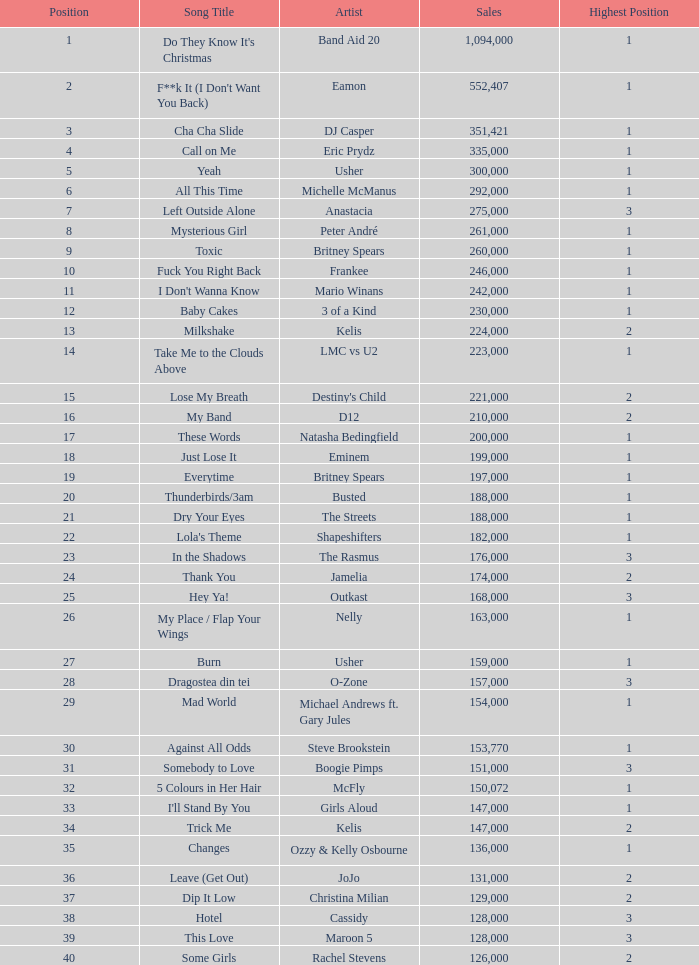Can you give me this table as a dict? {'header': ['Position', 'Song Title', 'Artist', 'Sales', 'Highest Position'], 'rows': [['1', "Do They Know It's Christmas", 'Band Aid 20', '1,094,000', '1'], ['2', "F**k It (I Don't Want You Back)", 'Eamon', '552,407', '1'], ['3', 'Cha Cha Slide', 'DJ Casper', '351,421', '1'], ['4', 'Call on Me', 'Eric Prydz', '335,000', '1'], ['5', 'Yeah', 'Usher', '300,000', '1'], ['6', 'All This Time', 'Michelle McManus', '292,000', '1'], ['7', 'Left Outside Alone', 'Anastacia', '275,000', '3'], ['8', 'Mysterious Girl', 'Peter André', '261,000', '1'], ['9', 'Toxic', 'Britney Spears', '260,000', '1'], ['10', 'Fuck You Right Back', 'Frankee', '246,000', '1'], ['11', "I Don't Wanna Know", 'Mario Winans', '242,000', '1'], ['12', 'Baby Cakes', '3 of a Kind', '230,000', '1'], ['13', 'Milkshake', 'Kelis', '224,000', '2'], ['14', 'Take Me to the Clouds Above', 'LMC vs U2', '223,000', '1'], ['15', 'Lose My Breath', "Destiny's Child", '221,000', '2'], ['16', 'My Band', 'D12', '210,000', '2'], ['17', 'These Words', 'Natasha Bedingfield', '200,000', '1'], ['18', 'Just Lose It', 'Eminem', '199,000', '1'], ['19', 'Everytime', 'Britney Spears', '197,000', '1'], ['20', 'Thunderbirds/3am', 'Busted', '188,000', '1'], ['21', 'Dry Your Eyes', 'The Streets', '188,000', '1'], ['22', "Lola's Theme", 'Shapeshifters', '182,000', '1'], ['23', 'In the Shadows', 'The Rasmus', '176,000', '3'], ['24', 'Thank You', 'Jamelia', '174,000', '2'], ['25', 'Hey Ya!', 'Outkast', '168,000', '3'], ['26', 'My Place / Flap Your Wings', 'Nelly', '163,000', '1'], ['27', 'Burn', 'Usher', '159,000', '1'], ['28', 'Dragostea din tei', 'O-Zone', '157,000', '3'], ['29', 'Mad World', 'Michael Andrews ft. Gary Jules', '154,000', '1'], ['30', 'Against All Odds', 'Steve Brookstein', '153,770', '1'], ['31', 'Somebody to Love', 'Boogie Pimps', '151,000', '3'], ['32', '5 Colours in Her Hair', 'McFly', '150,072', '1'], ['33', "I'll Stand By You", 'Girls Aloud', '147,000', '1'], ['34', 'Trick Me', 'Kelis', '147,000', '2'], ['35', 'Changes', 'Ozzy & Kelly Osbourne', '136,000', '1'], ['36', 'Leave (Get Out)', 'JoJo', '131,000', '2'], ['37', 'Dip It Low', 'Christina Milian', '129,000', '2'], ['38', 'Hotel', 'Cassidy', '128,000', '3'], ['39', 'This Love', 'Maroon 5', '128,000', '3'], ['40', 'Some Girls', 'Rachel Stevens', '126,000', '2']]} What is the maximum sales for a song with a ranking greater than 3? None. 